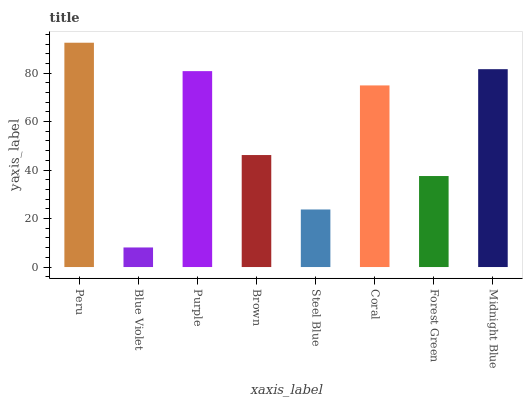Is Blue Violet the minimum?
Answer yes or no. Yes. Is Peru the maximum?
Answer yes or no. Yes. Is Purple the minimum?
Answer yes or no. No. Is Purple the maximum?
Answer yes or no. No. Is Purple greater than Blue Violet?
Answer yes or no. Yes. Is Blue Violet less than Purple?
Answer yes or no. Yes. Is Blue Violet greater than Purple?
Answer yes or no. No. Is Purple less than Blue Violet?
Answer yes or no. No. Is Coral the high median?
Answer yes or no. Yes. Is Brown the low median?
Answer yes or no. Yes. Is Brown the high median?
Answer yes or no. No. Is Midnight Blue the low median?
Answer yes or no. No. 